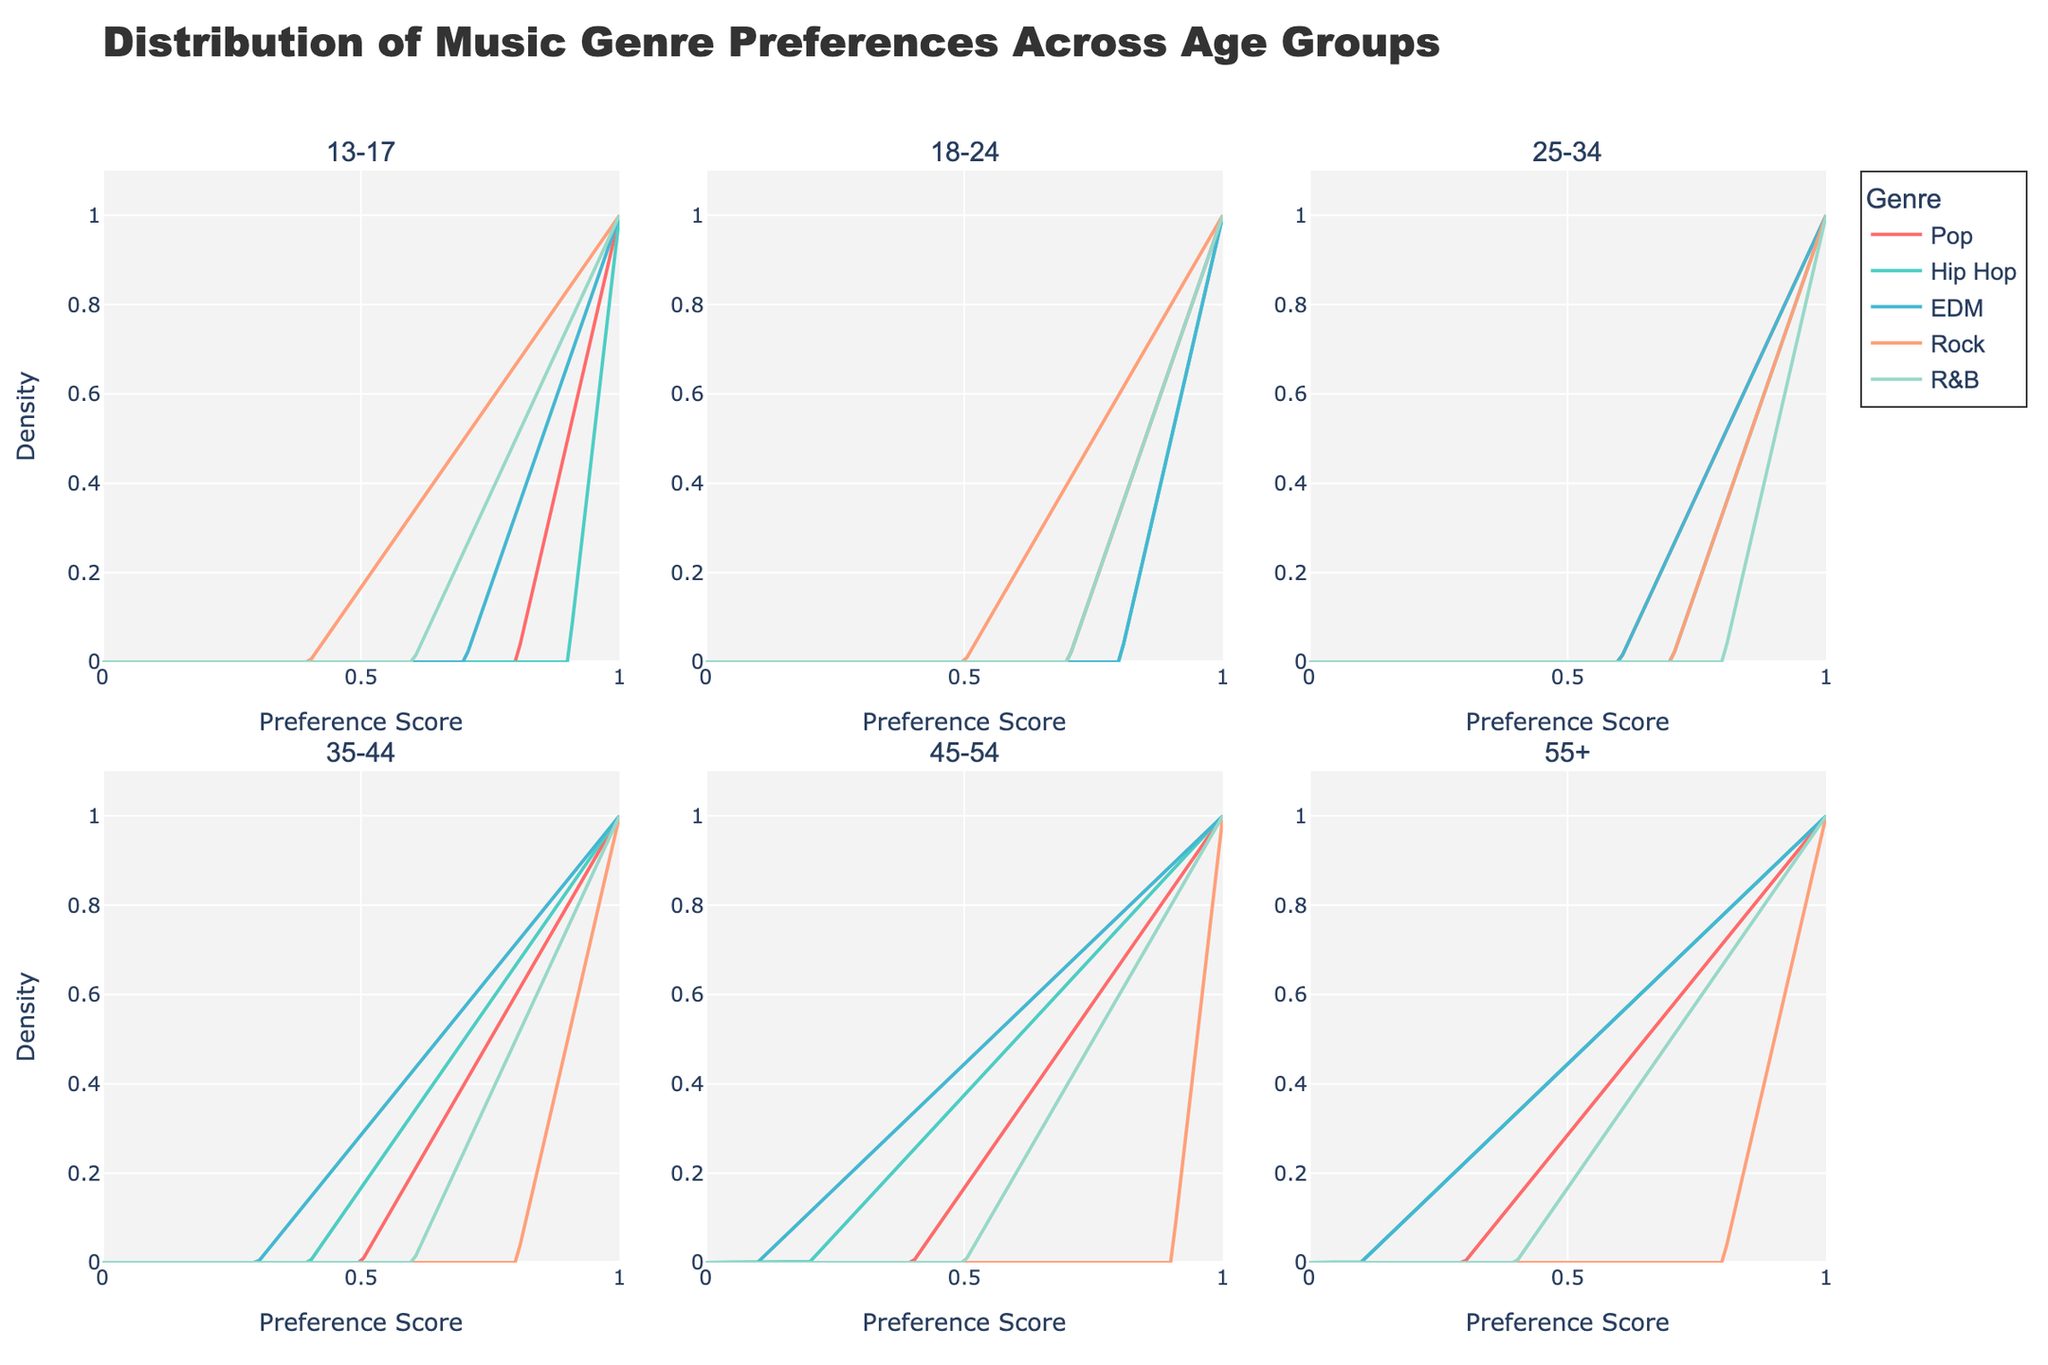Which age group has the highest preference score for Rock music? To find the highest preference score for Rock music, we need to look across all subplots. Among the age groups, the 45-54 age group has the highest preference score for Rock music, which is indicated by a preference score near 0.9.
Answer: 45-54 Which genre has the lowest preference score among the 55+ age group? To determine the lowest preference score among the 55+ age group, observe the curves in their subplot. EDM and Hip Hop both have the lowest preference scores, indicated by scores near 0.1.
Answer: EDM and Hip Hop Between the 13-17 and 18-24 age groups, which group shows a higher preference score for Hip Hop? Compare the density curves for Hip Hop in both the 13-17 and 18-24 subplots. The 13-17 age group has a higher preference score for Hip Hop, with a score of 0.9 compared to the 18-24 age group's score of 0.8.
Answer: 13-17 In which age group does Pop have the lowest preference score? Inspect the subplots for each age group to find the lowest preference score for Pop. The 55+ age group has the lowest preference score for Pop, with a score of 0.3.
Answer: 55+ Which age group shows the most balanced preference scores across all genres? Balance implies more equal heights of the density curves across genres. The 25-34 age group shows this balance, with most preference scores ranging relatively close to each other, around 0.6 to 0.8.
Answer: 25-34 What is the trend in preference scores for EDM as age increases? Examine the EDM preference scores across age groups in sequence. The trend shows a decrease in preference for EDM as age increases, from 0.7 in the 13-17 age group to 0.1 in the 55+ age group.
Answer: Decreasing Which genre has the highest preference score in the 25-34 age group? Look at the density curves for each genre in the 25-34 age group subplot. Rock and R&B have the highest preference scores, both near 0.8.
Answer: Rock and R&B For the 18-24 age group, which genre has the second highest preference score? Observe the density curves in the subplot for the 18-24 age group. The second highest preference score is for Hip Hop, which is 0.8, just below EDM which is also 0.8 but only Hip Hop being second highest.
Answer: Hip Hop 